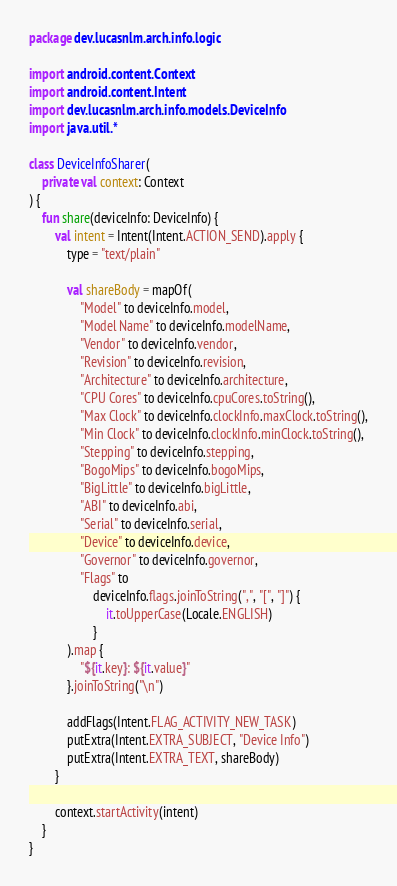Convert code to text. <code><loc_0><loc_0><loc_500><loc_500><_Kotlin_>package dev.lucasnlm.arch.info.logic

import android.content.Context
import android.content.Intent
import dev.lucasnlm.arch.info.models.DeviceInfo
import java.util.*

class DeviceInfoSharer(
    private val context: Context
) {
    fun share(deviceInfo: DeviceInfo) {
        val intent = Intent(Intent.ACTION_SEND).apply {
            type = "text/plain"

            val shareBody = mapOf(
                "Model" to deviceInfo.model,
                "Model Name" to deviceInfo.modelName,
                "Vendor" to deviceInfo.vendor,
                "Revision" to deviceInfo.revision,
                "Architecture" to deviceInfo.architecture,
                "CPU Cores" to deviceInfo.cpuCores.toString(),
                "Max Clock" to deviceInfo.clockInfo.maxClock.toString(),
                "Min Clock" to deviceInfo.clockInfo.minClock.toString(),
                "Stepping" to deviceInfo.stepping,
                "BogoMips" to deviceInfo.bogoMips,
                "BigLittle" to deviceInfo.bigLittle,
                "ABI" to deviceInfo.abi,
                "Serial" to deviceInfo.serial,
                "Device" to deviceInfo.device,
                "Governor" to deviceInfo.governor,
                "Flags" to
                    deviceInfo.flags.joinToString(",", "[", "]") {
                        it.toUpperCase(Locale.ENGLISH)
                    }
            ).map {
                "${it.key}: ${it.value}"
            }.joinToString("\n")

            addFlags(Intent.FLAG_ACTIVITY_NEW_TASK)
            putExtra(Intent.EXTRA_SUBJECT, "Device Info")
            putExtra(Intent.EXTRA_TEXT, shareBody)
        }

        context.startActivity(intent)
    }
}
</code> 